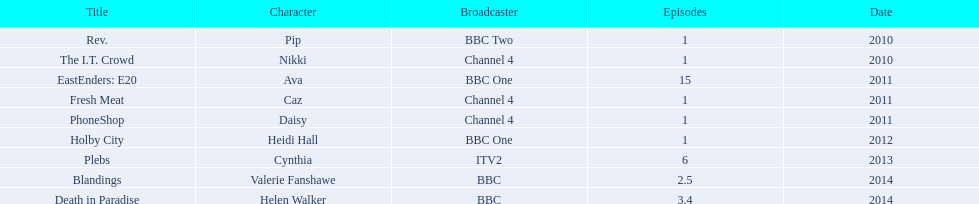What is the overall quantity of shows featuring sophie colguhoun? 9. 